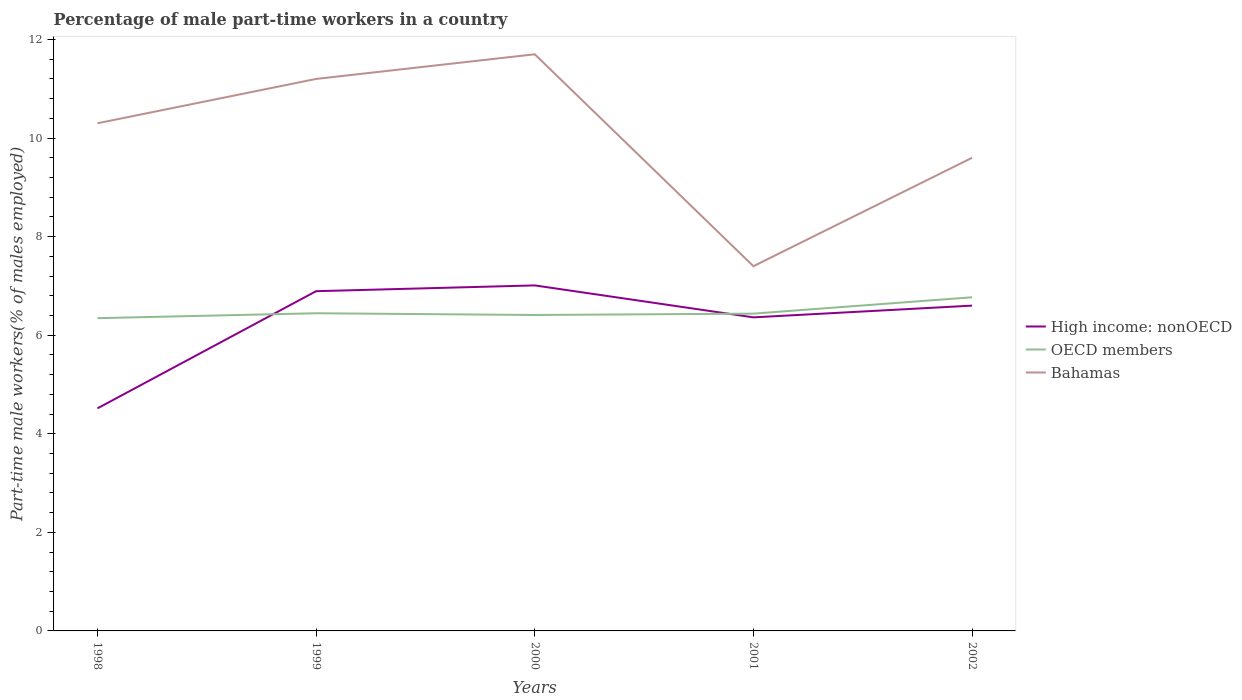How many different coloured lines are there?
Offer a terse response. 3. Does the line corresponding to Bahamas intersect with the line corresponding to OECD members?
Keep it short and to the point. No. Across all years, what is the maximum percentage of male part-time workers in OECD members?
Offer a very short reply. 6.35. What is the total percentage of male part-time workers in Bahamas in the graph?
Your answer should be compact. 4.3. What is the difference between the highest and the second highest percentage of male part-time workers in Bahamas?
Your answer should be compact. 4.3. What is the difference between the highest and the lowest percentage of male part-time workers in High income: nonOECD?
Your response must be concise. 4. Is the percentage of male part-time workers in OECD members strictly greater than the percentage of male part-time workers in High income: nonOECD over the years?
Offer a terse response. No. How many years are there in the graph?
Make the answer very short. 5. What is the difference between two consecutive major ticks on the Y-axis?
Offer a terse response. 2. Are the values on the major ticks of Y-axis written in scientific E-notation?
Give a very brief answer. No. What is the title of the graph?
Offer a very short reply. Percentage of male part-time workers in a country. Does "Bahrain" appear as one of the legend labels in the graph?
Provide a short and direct response. No. What is the label or title of the X-axis?
Provide a succinct answer. Years. What is the label or title of the Y-axis?
Offer a terse response. Part-time male workers(% of males employed). What is the Part-time male workers(% of males employed) of High income: nonOECD in 1998?
Make the answer very short. 4.52. What is the Part-time male workers(% of males employed) in OECD members in 1998?
Your answer should be very brief. 6.35. What is the Part-time male workers(% of males employed) of Bahamas in 1998?
Offer a terse response. 10.3. What is the Part-time male workers(% of males employed) of High income: nonOECD in 1999?
Your response must be concise. 6.89. What is the Part-time male workers(% of males employed) in OECD members in 1999?
Provide a short and direct response. 6.45. What is the Part-time male workers(% of males employed) in Bahamas in 1999?
Make the answer very short. 11.2. What is the Part-time male workers(% of males employed) in High income: nonOECD in 2000?
Your answer should be very brief. 7.01. What is the Part-time male workers(% of males employed) in OECD members in 2000?
Keep it short and to the point. 6.41. What is the Part-time male workers(% of males employed) in Bahamas in 2000?
Ensure brevity in your answer.  11.7. What is the Part-time male workers(% of males employed) of High income: nonOECD in 2001?
Your response must be concise. 6.36. What is the Part-time male workers(% of males employed) in OECD members in 2001?
Ensure brevity in your answer.  6.44. What is the Part-time male workers(% of males employed) in Bahamas in 2001?
Provide a succinct answer. 7.4. What is the Part-time male workers(% of males employed) of High income: nonOECD in 2002?
Give a very brief answer. 6.6. What is the Part-time male workers(% of males employed) of OECD members in 2002?
Your answer should be compact. 6.77. What is the Part-time male workers(% of males employed) in Bahamas in 2002?
Your answer should be compact. 9.6. Across all years, what is the maximum Part-time male workers(% of males employed) of High income: nonOECD?
Provide a short and direct response. 7.01. Across all years, what is the maximum Part-time male workers(% of males employed) in OECD members?
Your response must be concise. 6.77. Across all years, what is the maximum Part-time male workers(% of males employed) in Bahamas?
Your response must be concise. 11.7. Across all years, what is the minimum Part-time male workers(% of males employed) of High income: nonOECD?
Ensure brevity in your answer.  4.52. Across all years, what is the minimum Part-time male workers(% of males employed) in OECD members?
Your response must be concise. 6.35. Across all years, what is the minimum Part-time male workers(% of males employed) in Bahamas?
Offer a very short reply. 7.4. What is the total Part-time male workers(% of males employed) of High income: nonOECD in the graph?
Offer a very short reply. 31.38. What is the total Part-time male workers(% of males employed) of OECD members in the graph?
Make the answer very short. 32.41. What is the total Part-time male workers(% of males employed) of Bahamas in the graph?
Your answer should be very brief. 50.2. What is the difference between the Part-time male workers(% of males employed) of High income: nonOECD in 1998 and that in 1999?
Your response must be concise. -2.38. What is the difference between the Part-time male workers(% of males employed) in OECD members in 1998 and that in 1999?
Provide a succinct answer. -0.1. What is the difference between the Part-time male workers(% of males employed) of High income: nonOECD in 1998 and that in 2000?
Your answer should be compact. -2.49. What is the difference between the Part-time male workers(% of males employed) of OECD members in 1998 and that in 2000?
Keep it short and to the point. -0.06. What is the difference between the Part-time male workers(% of males employed) of Bahamas in 1998 and that in 2000?
Keep it short and to the point. -1.4. What is the difference between the Part-time male workers(% of males employed) of High income: nonOECD in 1998 and that in 2001?
Your answer should be very brief. -1.85. What is the difference between the Part-time male workers(% of males employed) of OECD members in 1998 and that in 2001?
Give a very brief answer. -0.09. What is the difference between the Part-time male workers(% of males employed) of Bahamas in 1998 and that in 2001?
Offer a terse response. 2.9. What is the difference between the Part-time male workers(% of males employed) in High income: nonOECD in 1998 and that in 2002?
Offer a terse response. -2.08. What is the difference between the Part-time male workers(% of males employed) of OECD members in 1998 and that in 2002?
Offer a terse response. -0.42. What is the difference between the Part-time male workers(% of males employed) in High income: nonOECD in 1999 and that in 2000?
Ensure brevity in your answer.  -0.12. What is the difference between the Part-time male workers(% of males employed) in OECD members in 1999 and that in 2000?
Make the answer very short. 0.04. What is the difference between the Part-time male workers(% of males employed) in High income: nonOECD in 1999 and that in 2001?
Offer a terse response. 0.53. What is the difference between the Part-time male workers(% of males employed) of OECD members in 1999 and that in 2001?
Offer a terse response. 0.01. What is the difference between the Part-time male workers(% of males employed) in Bahamas in 1999 and that in 2001?
Your answer should be very brief. 3.8. What is the difference between the Part-time male workers(% of males employed) of High income: nonOECD in 1999 and that in 2002?
Offer a very short reply. 0.29. What is the difference between the Part-time male workers(% of males employed) in OECD members in 1999 and that in 2002?
Provide a short and direct response. -0.32. What is the difference between the Part-time male workers(% of males employed) in High income: nonOECD in 2000 and that in 2001?
Keep it short and to the point. 0.65. What is the difference between the Part-time male workers(% of males employed) of OECD members in 2000 and that in 2001?
Provide a short and direct response. -0.03. What is the difference between the Part-time male workers(% of males employed) of High income: nonOECD in 2000 and that in 2002?
Give a very brief answer. 0.41. What is the difference between the Part-time male workers(% of males employed) in OECD members in 2000 and that in 2002?
Keep it short and to the point. -0.36. What is the difference between the Part-time male workers(% of males employed) of High income: nonOECD in 2001 and that in 2002?
Offer a very short reply. -0.24. What is the difference between the Part-time male workers(% of males employed) in OECD members in 2001 and that in 2002?
Keep it short and to the point. -0.33. What is the difference between the Part-time male workers(% of males employed) in High income: nonOECD in 1998 and the Part-time male workers(% of males employed) in OECD members in 1999?
Give a very brief answer. -1.93. What is the difference between the Part-time male workers(% of males employed) of High income: nonOECD in 1998 and the Part-time male workers(% of males employed) of Bahamas in 1999?
Give a very brief answer. -6.68. What is the difference between the Part-time male workers(% of males employed) in OECD members in 1998 and the Part-time male workers(% of males employed) in Bahamas in 1999?
Ensure brevity in your answer.  -4.85. What is the difference between the Part-time male workers(% of males employed) in High income: nonOECD in 1998 and the Part-time male workers(% of males employed) in OECD members in 2000?
Provide a succinct answer. -1.89. What is the difference between the Part-time male workers(% of males employed) in High income: nonOECD in 1998 and the Part-time male workers(% of males employed) in Bahamas in 2000?
Offer a terse response. -7.18. What is the difference between the Part-time male workers(% of males employed) in OECD members in 1998 and the Part-time male workers(% of males employed) in Bahamas in 2000?
Ensure brevity in your answer.  -5.35. What is the difference between the Part-time male workers(% of males employed) in High income: nonOECD in 1998 and the Part-time male workers(% of males employed) in OECD members in 2001?
Provide a succinct answer. -1.92. What is the difference between the Part-time male workers(% of males employed) of High income: nonOECD in 1998 and the Part-time male workers(% of males employed) of Bahamas in 2001?
Your response must be concise. -2.88. What is the difference between the Part-time male workers(% of males employed) in OECD members in 1998 and the Part-time male workers(% of males employed) in Bahamas in 2001?
Your answer should be compact. -1.05. What is the difference between the Part-time male workers(% of males employed) in High income: nonOECD in 1998 and the Part-time male workers(% of males employed) in OECD members in 2002?
Make the answer very short. -2.25. What is the difference between the Part-time male workers(% of males employed) of High income: nonOECD in 1998 and the Part-time male workers(% of males employed) of Bahamas in 2002?
Offer a terse response. -5.08. What is the difference between the Part-time male workers(% of males employed) in OECD members in 1998 and the Part-time male workers(% of males employed) in Bahamas in 2002?
Make the answer very short. -3.25. What is the difference between the Part-time male workers(% of males employed) of High income: nonOECD in 1999 and the Part-time male workers(% of males employed) of OECD members in 2000?
Your response must be concise. 0.48. What is the difference between the Part-time male workers(% of males employed) of High income: nonOECD in 1999 and the Part-time male workers(% of males employed) of Bahamas in 2000?
Provide a succinct answer. -4.81. What is the difference between the Part-time male workers(% of males employed) in OECD members in 1999 and the Part-time male workers(% of males employed) in Bahamas in 2000?
Provide a short and direct response. -5.25. What is the difference between the Part-time male workers(% of males employed) in High income: nonOECD in 1999 and the Part-time male workers(% of males employed) in OECD members in 2001?
Your answer should be very brief. 0.46. What is the difference between the Part-time male workers(% of males employed) of High income: nonOECD in 1999 and the Part-time male workers(% of males employed) of Bahamas in 2001?
Offer a very short reply. -0.51. What is the difference between the Part-time male workers(% of males employed) of OECD members in 1999 and the Part-time male workers(% of males employed) of Bahamas in 2001?
Provide a succinct answer. -0.95. What is the difference between the Part-time male workers(% of males employed) in High income: nonOECD in 1999 and the Part-time male workers(% of males employed) in OECD members in 2002?
Keep it short and to the point. 0.12. What is the difference between the Part-time male workers(% of males employed) in High income: nonOECD in 1999 and the Part-time male workers(% of males employed) in Bahamas in 2002?
Ensure brevity in your answer.  -2.71. What is the difference between the Part-time male workers(% of males employed) in OECD members in 1999 and the Part-time male workers(% of males employed) in Bahamas in 2002?
Your response must be concise. -3.15. What is the difference between the Part-time male workers(% of males employed) of High income: nonOECD in 2000 and the Part-time male workers(% of males employed) of OECD members in 2001?
Keep it short and to the point. 0.57. What is the difference between the Part-time male workers(% of males employed) of High income: nonOECD in 2000 and the Part-time male workers(% of males employed) of Bahamas in 2001?
Your answer should be compact. -0.39. What is the difference between the Part-time male workers(% of males employed) in OECD members in 2000 and the Part-time male workers(% of males employed) in Bahamas in 2001?
Ensure brevity in your answer.  -0.99. What is the difference between the Part-time male workers(% of males employed) of High income: nonOECD in 2000 and the Part-time male workers(% of males employed) of OECD members in 2002?
Provide a succinct answer. 0.24. What is the difference between the Part-time male workers(% of males employed) in High income: nonOECD in 2000 and the Part-time male workers(% of males employed) in Bahamas in 2002?
Provide a succinct answer. -2.59. What is the difference between the Part-time male workers(% of males employed) in OECD members in 2000 and the Part-time male workers(% of males employed) in Bahamas in 2002?
Provide a succinct answer. -3.19. What is the difference between the Part-time male workers(% of males employed) in High income: nonOECD in 2001 and the Part-time male workers(% of males employed) in OECD members in 2002?
Make the answer very short. -0.41. What is the difference between the Part-time male workers(% of males employed) of High income: nonOECD in 2001 and the Part-time male workers(% of males employed) of Bahamas in 2002?
Give a very brief answer. -3.24. What is the difference between the Part-time male workers(% of males employed) in OECD members in 2001 and the Part-time male workers(% of males employed) in Bahamas in 2002?
Make the answer very short. -3.16. What is the average Part-time male workers(% of males employed) of High income: nonOECD per year?
Provide a short and direct response. 6.28. What is the average Part-time male workers(% of males employed) of OECD members per year?
Give a very brief answer. 6.48. What is the average Part-time male workers(% of males employed) in Bahamas per year?
Provide a short and direct response. 10.04. In the year 1998, what is the difference between the Part-time male workers(% of males employed) in High income: nonOECD and Part-time male workers(% of males employed) in OECD members?
Provide a succinct answer. -1.83. In the year 1998, what is the difference between the Part-time male workers(% of males employed) of High income: nonOECD and Part-time male workers(% of males employed) of Bahamas?
Keep it short and to the point. -5.78. In the year 1998, what is the difference between the Part-time male workers(% of males employed) of OECD members and Part-time male workers(% of males employed) of Bahamas?
Keep it short and to the point. -3.95. In the year 1999, what is the difference between the Part-time male workers(% of males employed) of High income: nonOECD and Part-time male workers(% of males employed) of OECD members?
Your response must be concise. 0.45. In the year 1999, what is the difference between the Part-time male workers(% of males employed) in High income: nonOECD and Part-time male workers(% of males employed) in Bahamas?
Offer a terse response. -4.31. In the year 1999, what is the difference between the Part-time male workers(% of males employed) in OECD members and Part-time male workers(% of males employed) in Bahamas?
Offer a very short reply. -4.75. In the year 2000, what is the difference between the Part-time male workers(% of males employed) in High income: nonOECD and Part-time male workers(% of males employed) in OECD members?
Give a very brief answer. 0.6. In the year 2000, what is the difference between the Part-time male workers(% of males employed) in High income: nonOECD and Part-time male workers(% of males employed) in Bahamas?
Your answer should be very brief. -4.69. In the year 2000, what is the difference between the Part-time male workers(% of males employed) in OECD members and Part-time male workers(% of males employed) in Bahamas?
Offer a terse response. -5.29. In the year 2001, what is the difference between the Part-time male workers(% of males employed) of High income: nonOECD and Part-time male workers(% of males employed) of OECD members?
Your answer should be compact. -0.08. In the year 2001, what is the difference between the Part-time male workers(% of males employed) in High income: nonOECD and Part-time male workers(% of males employed) in Bahamas?
Provide a succinct answer. -1.04. In the year 2001, what is the difference between the Part-time male workers(% of males employed) of OECD members and Part-time male workers(% of males employed) of Bahamas?
Offer a very short reply. -0.96. In the year 2002, what is the difference between the Part-time male workers(% of males employed) in High income: nonOECD and Part-time male workers(% of males employed) in OECD members?
Ensure brevity in your answer.  -0.17. In the year 2002, what is the difference between the Part-time male workers(% of males employed) in High income: nonOECD and Part-time male workers(% of males employed) in Bahamas?
Make the answer very short. -3. In the year 2002, what is the difference between the Part-time male workers(% of males employed) in OECD members and Part-time male workers(% of males employed) in Bahamas?
Make the answer very short. -2.83. What is the ratio of the Part-time male workers(% of males employed) in High income: nonOECD in 1998 to that in 1999?
Keep it short and to the point. 0.66. What is the ratio of the Part-time male workers(% of males employed) of OECD members in 1998 to that in 1999?
Your response must be concise. 0.98. What is the ratio of the Part-time male workers(% of males employed) of Bahamas in 1998 to that in 1999?
Your response must be concise. 0.92. What is the ratio of the Part-time male workers(% of males employed) of High income: nonOECD in 1998 to that in 2000?
Provide a short and direct response. 0.64. What is the ratio of the Part-time male workers(% of males employed) of OECD members in 1998 to that in 2000?
Offer a very short reply. 0.99. What is the ratio of the Part-time male workers(% of males employed) of Bahamas in 1998 to that in 2000?
Ensure brevity in your answer.  0.88. What is the ratio of the Part-time male workers(% of males employed) of High income: nonOECD in 1998 to that in 2001?
Offer a very short reply. 0.71. What is the ratio of the Part-time male workers(% of males employed) of OECD members in 1998 to that in 2001?
Your answer should be very brief. 0.99. What is the ratio of the Part-time male workers(% of males employed) in Bahamas in 1998 to that in 2001?
Your answer should be compact. 1.39. What is the ratio of the Part-time male workers(% of males employed) of High income: nonOECD in 1998 to that in 2002?
Make the answer very short. 0.68. What is the ratio of the Part-time male workers(% of males employed) of OECD members in 1998 to that in 2002?
Provide a succinct answer. 0.94. What is the ratio of the Part-time male workers(% of males employed) of Bahamas in 1998 to that in 2002?
Make the answer very short. 1.07. What is the ratio of the Part-time male workers(% of males employed) in High income: nonOECD in 1999 to that in 2000?
Your response must be concise. 0.98. What is the ratio of the Part-time male workers(% of males employed) in OECD members in 1999 to that in 2000?
Make the answer very short. 1.01. What is the ratio of the Part-time male workers(% of males employed) in Bahamas in 1999 to that in 2000?
Provide a succinct answer. 0.96. What is the ratio of the Part-time male workers(% of males employed) of High income: nonOECD in 1999 to that in 2001?
Offer a terse response. 1.08. What is the ratio of the Part-time male workers(% of males employed) of OECD members in 1999 to that in 2001?
Provide a short and direct response. 1. What is the ratio of the Part-time male workers(% of males employed) in Bahamas in 1999 to that in 2001?
Your answer should be very brief. 1.51. What is the ratio of the Part-time male workers(% of males employed) in High income: nonOECD in 1999 to that in 2002?
Offer a very short reply. 1.04. What is the ratio of the Part-time male workers(% of males employed) in OECD members in 1999 to that in 2002?
Ensure brevity in your answer.  0.95. What is the ratio of the Part-time male workers(% of males employed) in High income: nonOECD in 2000 to that in 2001?
Your answer should be compact. 1.1. What is the ratio of the Part-time male workers(% of males employed) in OECD members in 2000 to that in 2001?
Keep it short and to the point. 1. What is the ratio of the Part-time male workers(% of males employed) in Bahamas in 2000 to that in 2001?
Make the answer very short. 1.58. What is the ratio of the Part-time male workers(% of males employed) of High income: nonOECD in 2000 to that in 2002?
Provide a succinct answer. 1.06. What is the ratio of the Part-time male workers(% of males employed) of OECD members in 2000 to that in 2002?
Keep it short and to the point. 0.95. What is the ratio of the Part-time male workers(% of males employed) in Bahamas in 2000 to that in 2002?
Offer a very short reply. 1.22. What is the ratio of the Part-time male workers(% of males employed) in High income: nonOECD in 2001 to that in 2002?
Make the answer very short. 0.96. What is the ratio of the Part-time male workers(% of males employed) of OECD members in 2001 to that in 2002?
Provide a succinct answer. 0.95. What is the ratio of the Part-time male workers(% of males employed) of Bahamas in 2001 to that in 2002?
Provide a succinct answer. 0.77. What is the difference between the highest and the second highest Part-time male workers(% of males employed) in High income: nonOECD?
Your answer should be very brief. 0.12. What is the difference between the highest and the second highest Part-time male workers(% of males employed) in OECD members?
Provide a short and direct response. 0.32. What is the difference between the highest and the lowest Part-time male workers(% of males employed) in High income: nonOECD?
Make the answer very short. 2.49. What is the difference between the highest and the lowest Part-time male workers(% of males employed) in OECD members?
Offer a very short reply. 0.42. What is the difference between the highest and the lowest Part-time male workers(% of males employed) in Bahamas?
Provide a succinct answer. 4.3. 